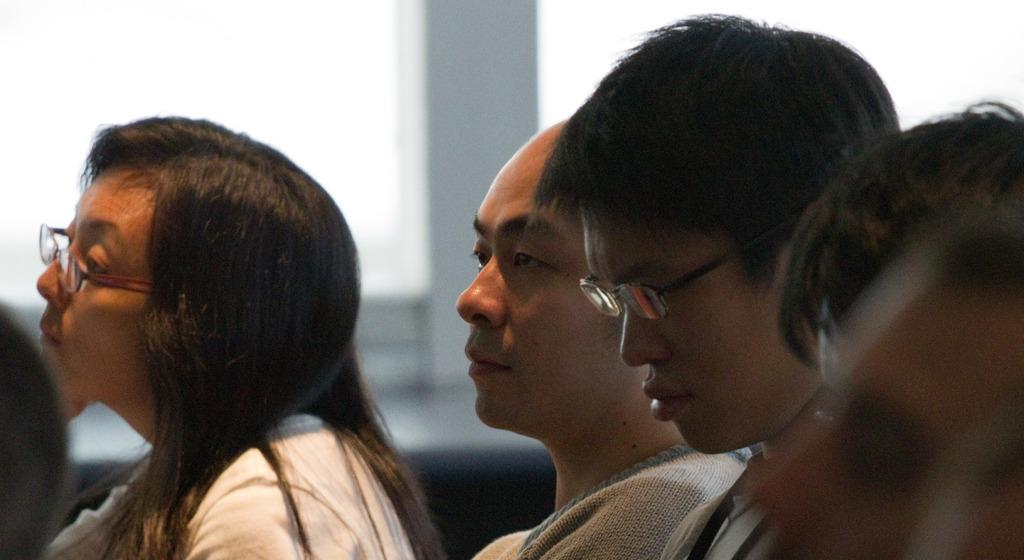How many people are in the image? There are three people in the image: one woman and two men. What can be observed about the woman and one of the men? The woman and one of the men are wearing spectacles. Can you describe the eyewear that the woman and one of the men are wearing? They are wearing spectacles, which are a type of eyewear used to correct vision. What type of zebra can be seen in the image? There is no zebra present in the image. What sign is visible in the image? There is no sign visible in the image. 